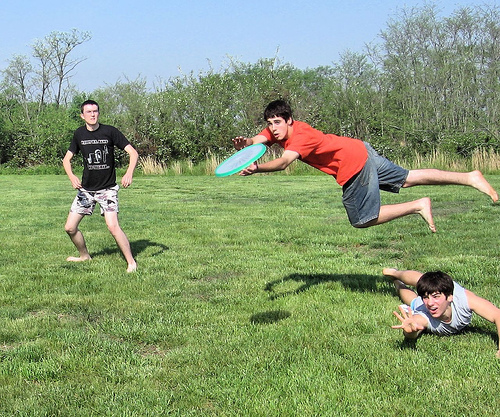Please provide a short description for this region: [0.11, 0.27, 0.31, 0.63]. A man wearing a black shirt standing on the grass. 